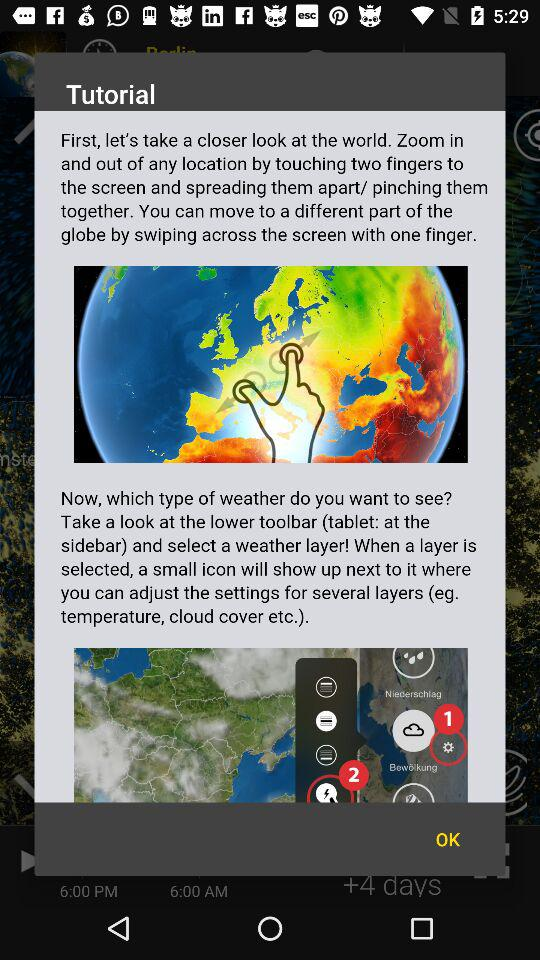How many fingers do you need to zoom in or out of a location?
Answer the question using a single word or phrase. Two 